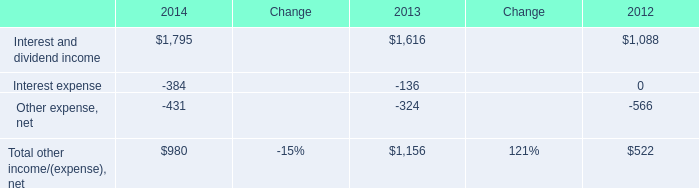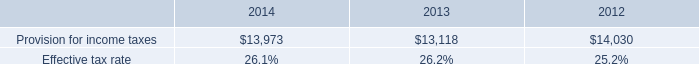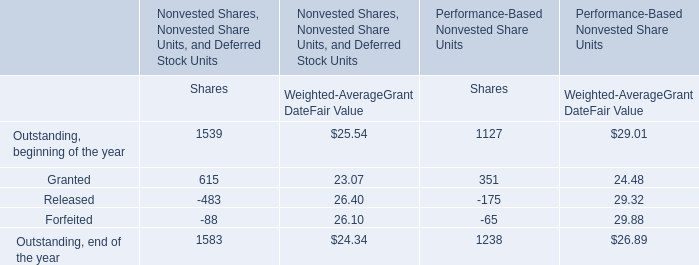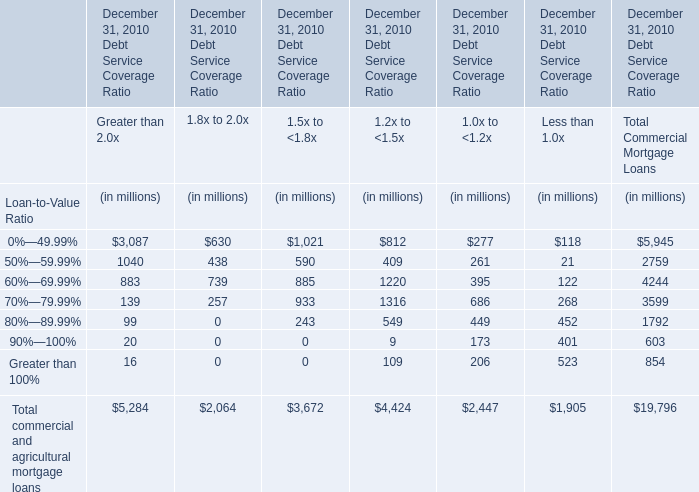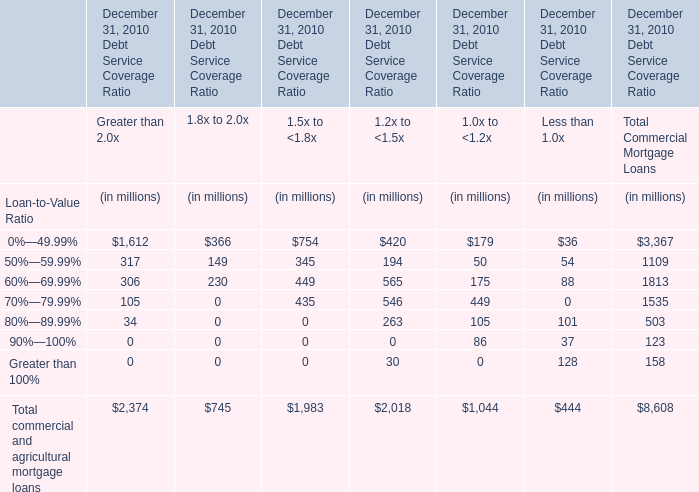What is the average amount of Provision for income taxes of 2014, and Interest and dividend income of 2012 ? 
Computations: ((13973.0 + 1088.0) / 2)
Answer: 7530.5. 